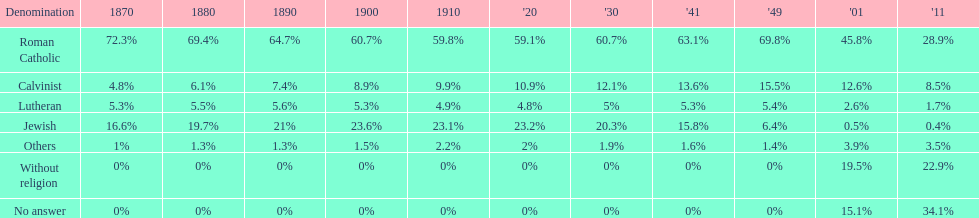The percentage of people who identified as calvinist was, at most, how much? 15.5%. 